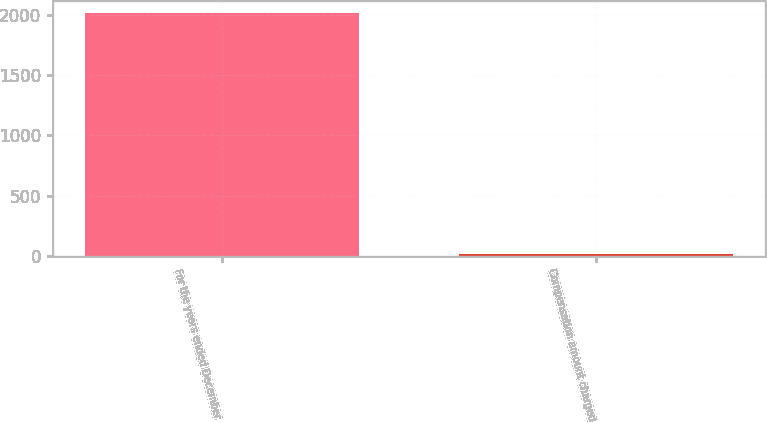Convert chart. <chart><loc_0><loc_0><loc_500><loc_500><bar_chart><fcel>For the years ended December<fcel>Compensation amount charged<nl><fcel>2011<fcel>21<nl></chart> 